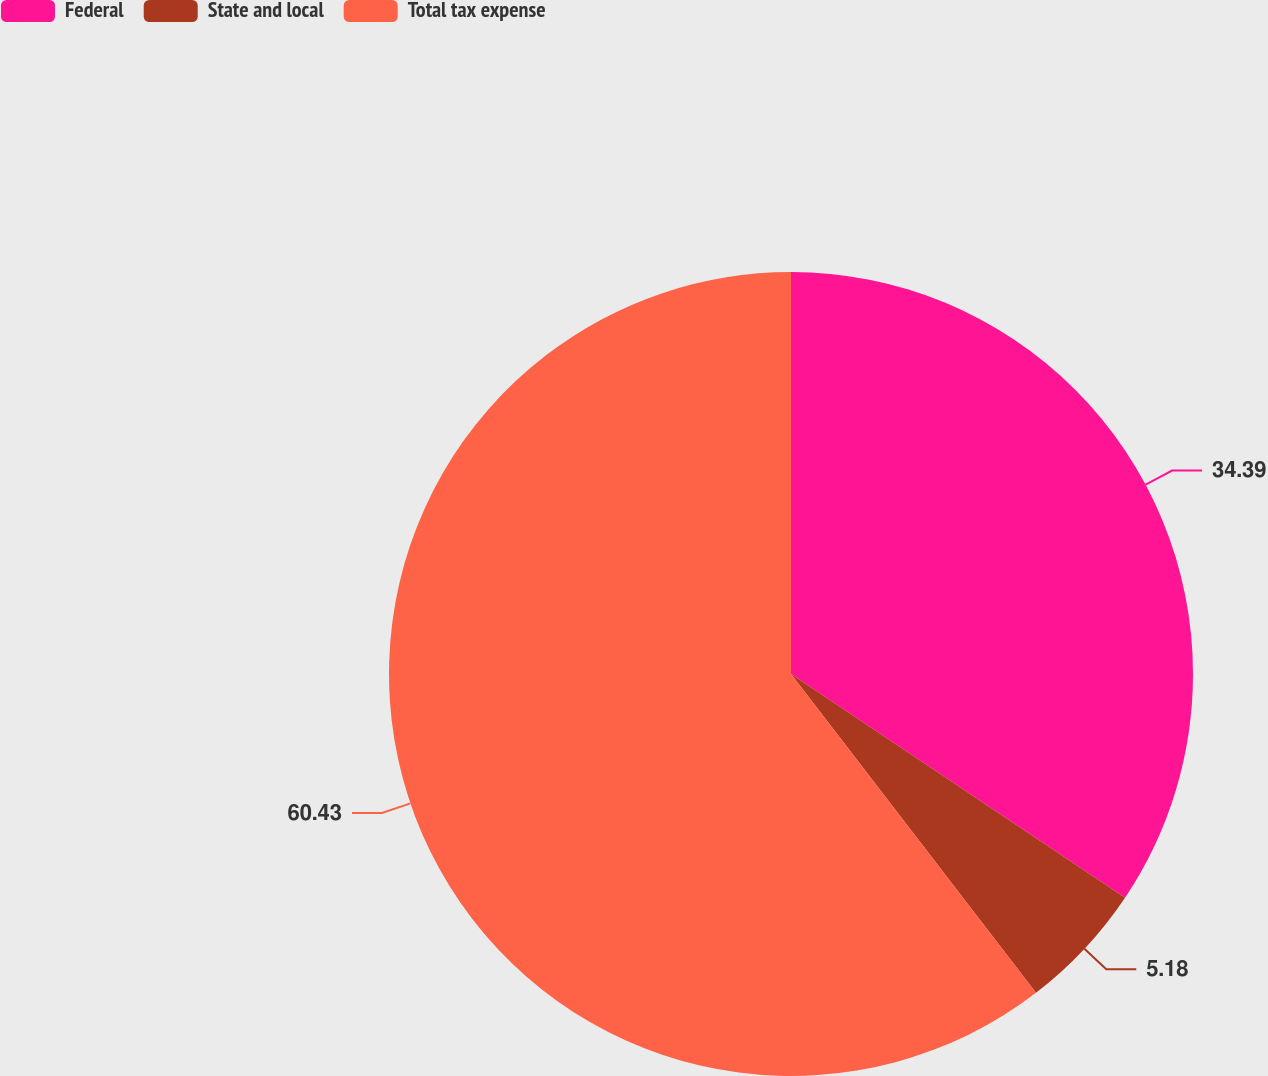Convert chart to OTSL. <chart><loc_0><loc_0><loc_500><loc_500><pie_chart><fcel>Federal<fcel>State and local<fcel>Total tax expense<nl><fcel>34.39%<fcel>5.18%<fcel>60.43%<nl></chart> 